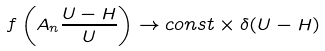Convert formula to latex. <formula><loc_0><loc_0><loc_500><loc_500>f \left ( A _ { n } \frac { U - H } { U } \right ) \rightarrow c o n s t \times \delta ( U - H )</formula> 